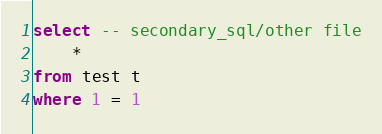<code> <loc_0><loc_0><loc_500><loc_500><_SQL_>select -- secondary_sql/other file
	*
from test t
where 1 = 1
</code> 